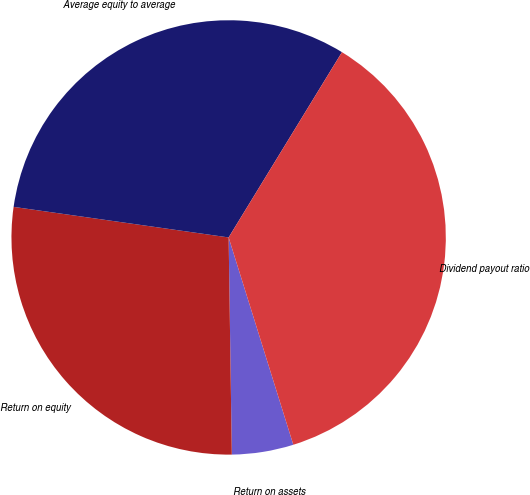Convert chart to OTSL. <chart><loc_0><loc_0><loc_500><loc_500><pie_chart><fcel>Return on assets<fcel>Return on equity<fcel>Average equity to average<fcel>Dividend payout ratio<nl><fcel>4.58%<fcel>27.48%<fcel>31.49%<fcel>36.45%<nl></chart> 